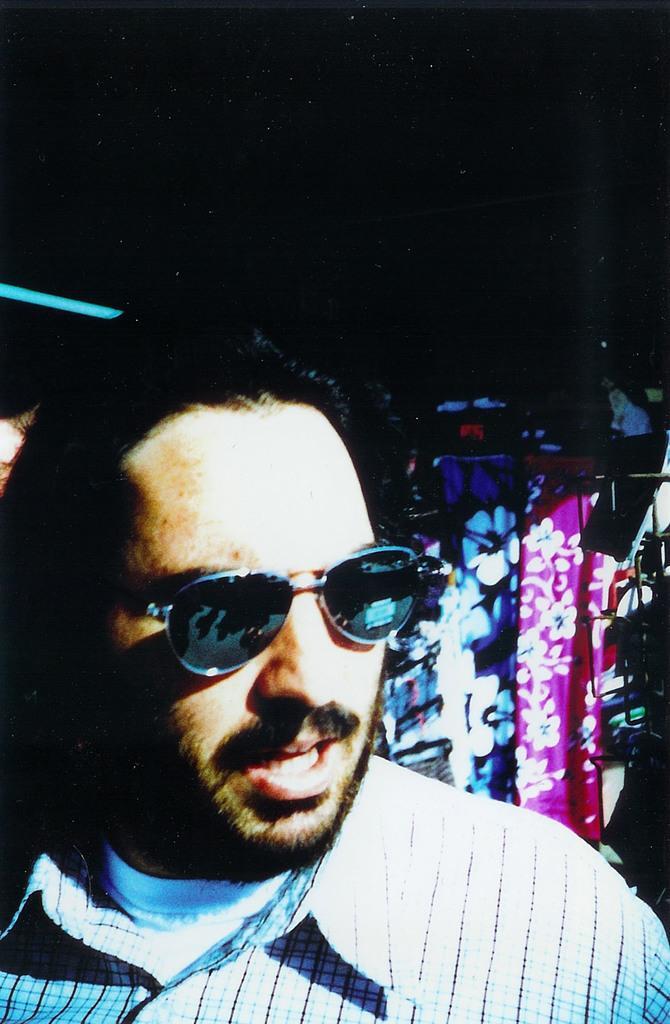How would you summarize this image in a sentence or two? In this image I can see a man is talking, he wore shirt, spectacles. On the right side there is a cloth in purple color and another cloth with flowers 